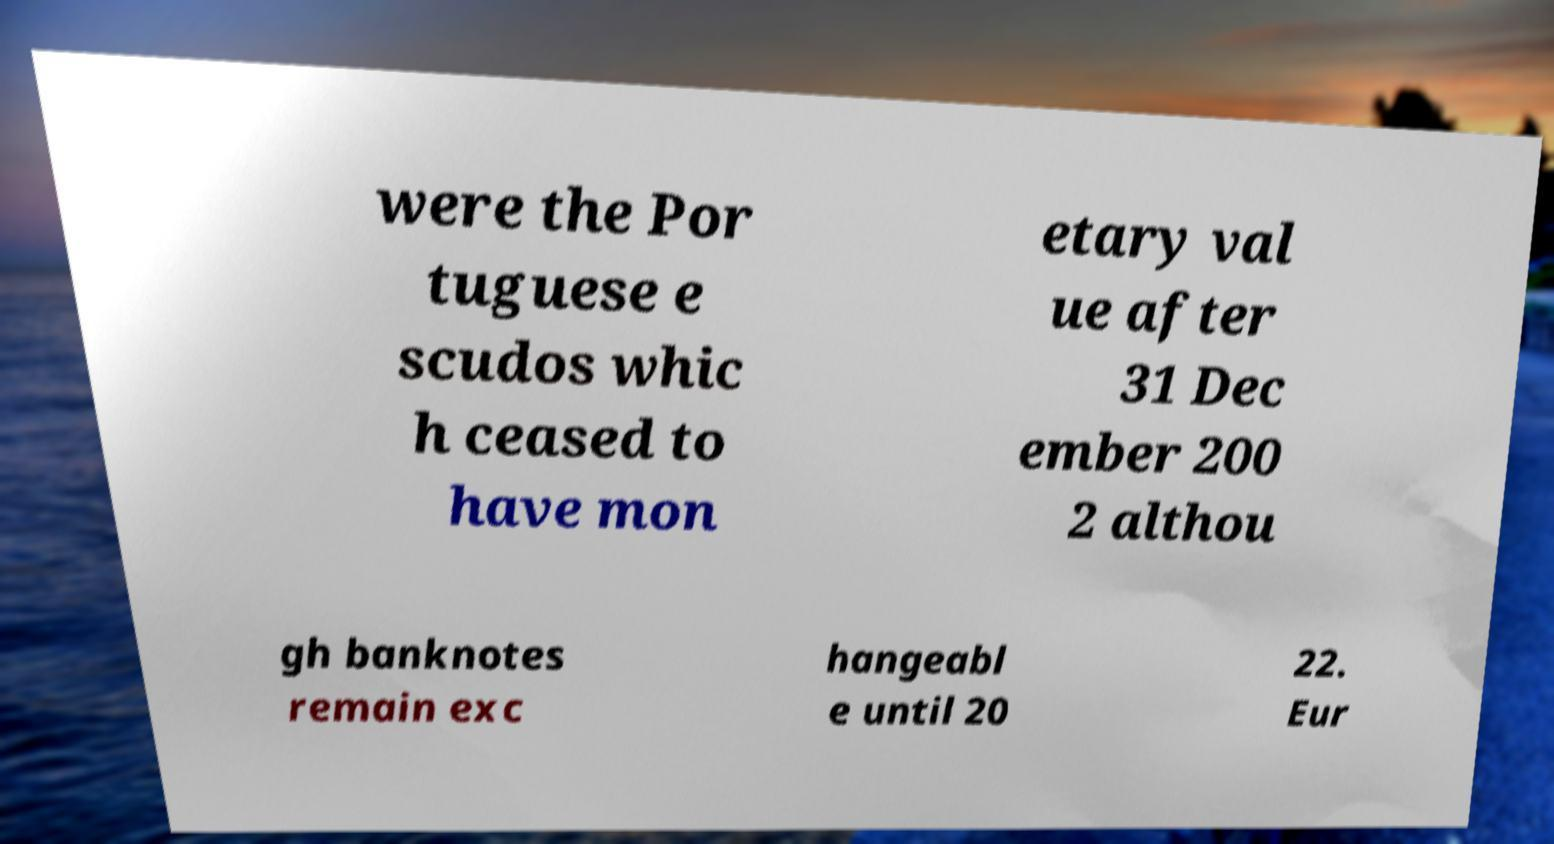There's text embedded in this image that I need extracted. Can you transcribe it verbatim? were the Por tuguese e scudos whic h ceased to have mon etary val ue after 31 Dec ember 200 2 althou gh banknotes remain exc hangeabl e until 20 22. Eur 